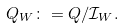Convert formula to latex. <formula><loc_0><loc_0><loc_500><loc_500>Q _ { W } \colon = Q / \mathcal { I } _ { W } .</formula> 